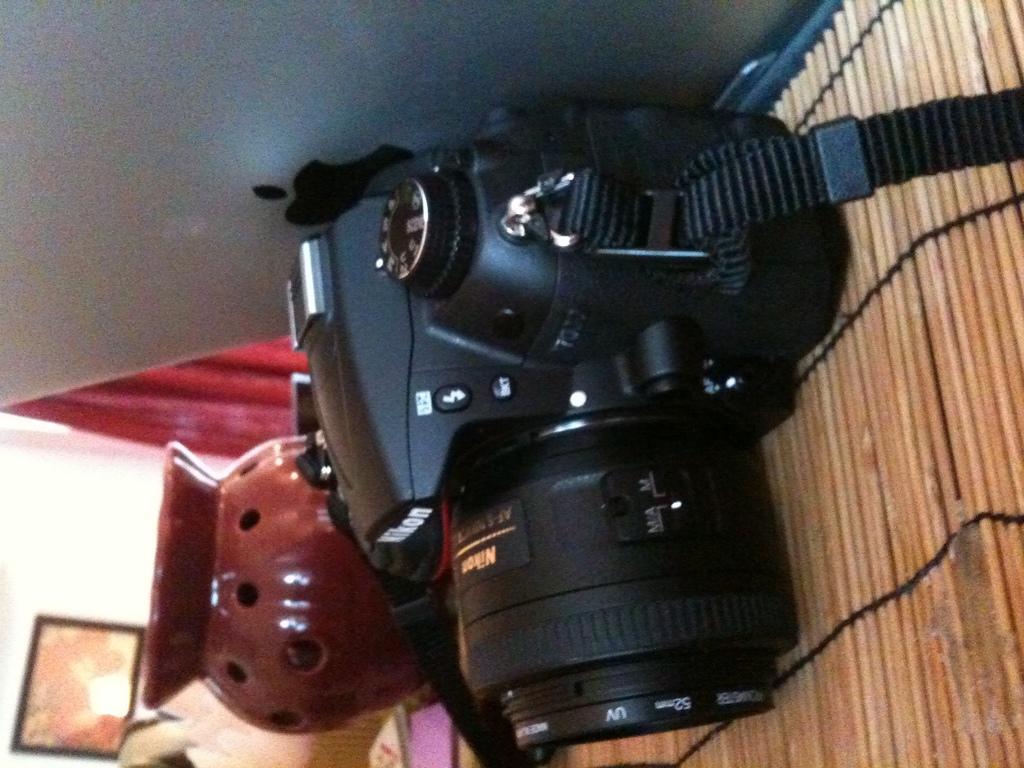In one or two sentences, can you explain what this image depicts? In this picture we can see a camera, laptop, pot, curtain, frame on the wall and some objects. 